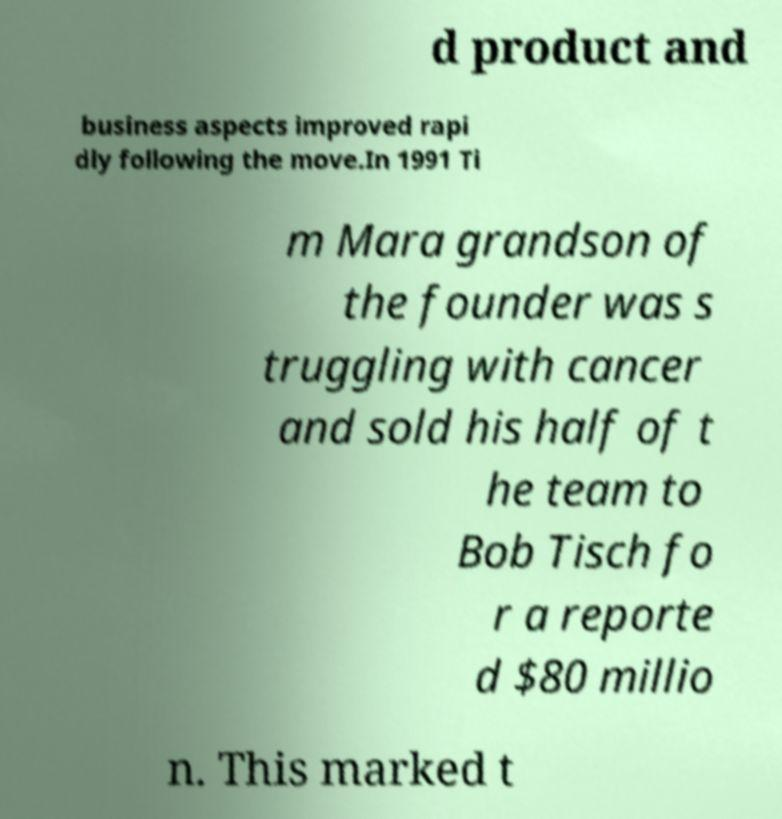For documentation purposes, I need the text within this image transcribed. Could you provide that? d product and business aspects improved rapi dly following the move.In 1991 Ti m Mara grandson of the founder was s truggling with cancer and sold his half of t he team to Bob Tisch fo r a reporte d $80 millio n. This marked t 